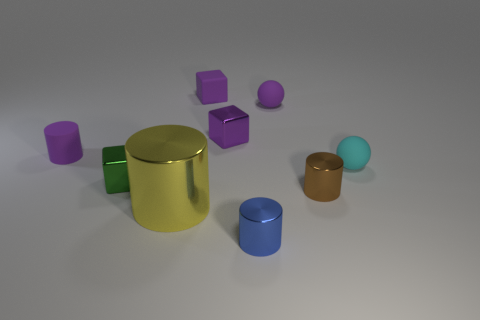What is the material of the small purple cylinder?
Offer a very short reply. Rubber. How many large things are either metal objects or purple metal blocks?
Provide a short and direct response. 1. There is a blue thing; how many green blocks are left of it?
Offer a very short reply. 1. Is there a tiny rubber thing of the same color as the rubber cube?
Provide a succinct answer. Yes. What shape is the green thing that is the same size as the purple metal cube?
Your answer should be compact. Cube. What number of red things are either balls or tiny blocks?
Make the answer very short. 0. What number of green shiny things have the same size as the cyan rubber thing?
Offer a very short reply. 1. There is a tiny shiny object that is the same color as the matte cylinder; what shape is it?
Your answer should be compact. Cube. How many things are purple things or purple things that are to the left of the blue shiny cylinder?
Offer a terse response. 4. There is a cylinder that is behind the brown cylinder; is its size the same as the sphere that is on the left side of the brown shiny thing?
Provide a short and direct response. Yes. 